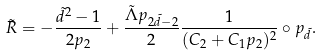Convert formula to latex. <formula><loc_0><loc_0><loc_500><loc_500>\tilde { R } = - \frac { \tilde { d } ^ { 2 } - 1 } { 2 p _ { 2 } } + \frac { \tilde { \Lambda } p _ { 2 \tilde { d } - 2 } } { 2 } \frac { 1 } { ( C _ { 2 } + C _ { 1 } p _ { 2 } ) ^ { 2 } } \circ p _ { \tilde { d } } .</formula> 